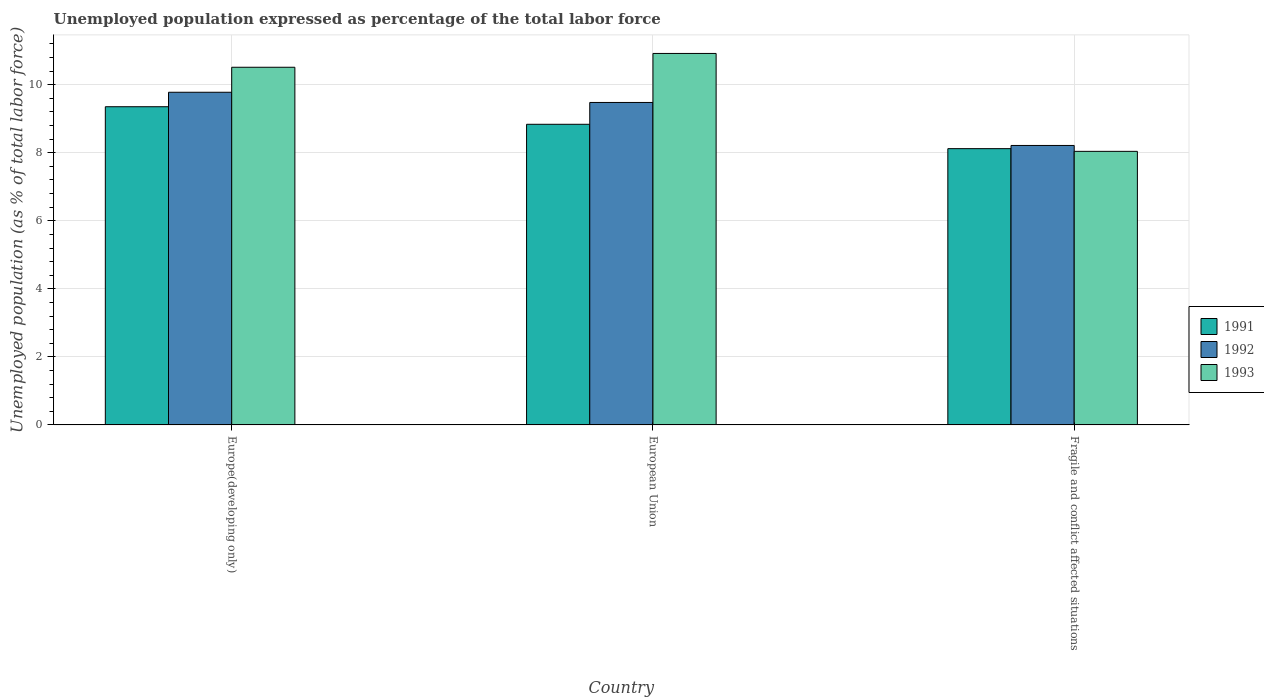How many groups of bars are there?
Give a very brief answer. 3. How many bars are there on the 3rd tick from the left?
Your answer should be very brief. 3. What is the label of the 1st group of bars from the left?
Make the answer very short. Europe(developing only). What is the unemployment in in 1992 in Europe(developing only)?
Provide a short and direct response. 9.78. Across all countries, what is the maximum unemployment in in 1993?
Your answer should be compact. 10.92. Across all countries, what is the minimum unemployment in in 1992?
Provide a short and direct response. 8.22. In which country was the unemployment in in 1992 minimum?
Your answer should be compact. Fragile and conflict affected situations. What is the total unemployment in in 1992 in the graph?
Your answer should be compact. 27.47. What is the difference between the unemployment in in 1992 in Europe(developing only) and that in European Union?
Ensure brevity in your answer.  0.3. What is the difference between the unemployment in in 1991 in Fragile and conflict affected situations and the unemployment in in 1992 in European Union?
Provide a short and direct response. -1.36. What is the average unemployment in in 1991 per country?
Your answer should be compact. 8.77. What is the difference between the unemployment in of/in 1991 and unemployment in of/in 1992 in Europe(developing only)?
Ensure brevity in your answer.  -0.43. What is the ratio of the unemployment in in 1991 in Europe(developing only) to that in European Union?
Offer a very short reply. 1.06. Is the unemployment in in 1993 in Europe(developing only) less than that in Fragile and conflict affected situations?
Your response must be concise. No. Is the difference between the unemployment in in 1991 in European Union and Fragile and conflict affected situations greater than the difference between the unemployment in in 1992 in European Union and Fragile and conflict affected situations?
Ensure brevity in your answer.  No. What is the difference between the highest and the second highest unemployment in in 1991?
Make the answer very short. -0.52. What is the difference between the highest and the lowest unemployment in in 1993?
Give a very brief answer. 2.88. What does the 1st bar from the left in Europe(developing only) represents?
Your response must be concise. 1991. How many bars are there?
Keep it short and to the point. 9. Are all the bars in the graph horizontal?
Your answer should be very brief. No. How many countries are there in the graph?
Keep it short and to the point. 3. Are the values on the major ticks of Y-axis written in scientific E-notation?
Keep it short and to the point. No. Does the graph contain any zero values?
Offer a very short reply. No. How many legend labels are there?
Your answer should be very brief. 3. How are the legend labels stacked?
Provide a succinct answer. Vertical. What is the title of the graph?
Offer a terse response. Unemployed population expressed as percentage of the total labor force. What is the label or title of the Y-axis?
Keep it short and to the point. Unemployed population (as % of total labor force). What is the Unemployed population (as % of total labor force) of 1991 in Europe(developing only)?
Provide a short and direct response. 9.35. What is the Unemployed population (as % of total labor force) in 1992 in Europe(developing only)?
Provide a short and direct response. 9.78. What is the Unemployed population (as % of total labor force) in 1993 in Europe(developing only)?
Offer a very short reply. 10.51. What is the Unemployed population (as % of total labor force) in 1991 in European Union?
Offer a very short reply. 8.84. What is the Unemployed population (as % of total labor force) in 1992 in European Union?
Offer a very short reply. 9.48. What is the Unemployed population (as % of total labor force) of 1993 in European Union?
Your response must be concise. 10.92. What is the Unemployed population (as % of total labor force) of 1991 in Fragile and conflict affected situations?
Ensure brevity in your answer.  8.12. What is the Unemployed population (as % of total labor force) of 1992 in Fragile and conflict affected situations?
Provide a succinct answer. 8.22. What is the Unemployed population (as % of total labor force) in 1993 in Fragile and conflict affected situations?
Ensure brevity in your answer.  8.04. Across all countries, what is the maximum Unemployed population (as % of total labor force) of 1991?
Give a very brief answer. 9.35. Across all countries, what is the maximum Unemployed population (as % of total labor force) in 1992?
Offer a very short reply. 9.78. Across all countries, what is the maximum Unemployed population (as % of total labor force) of 1993?
Provide a short and direct response. 10.92. Across all countries, what is the minimum Unemployed population (as % of total labor force) of 1991?
Keep it short and to the point. 8.12. Across all countries, what is the minimum Unemployed population (as % of total labor force) in 1992?
Your answer should be very brief. 8.22. Across all countries, what is the minimum Unemployed population (as % of total labor force) of 1993?
Your answer should be compact. 8.04. What is the total Unemployed population (as % of total labor force) of 1991 in the graph?
Give a very brief answer. 26.31. What is the total Unemployed population (as % of total labor force) of 1992 in the graph?
Offer a terse response. 27.47. What is the total Unemployed population (as % of total labor force) in 1993 in the graph?
Your response must be concise. 29.48. What is the difference between the Unemployed population (as % of total labor force) in 1991 in Europe(developing only) and that in European Union?
Provide a short and direct response. 0.52. What is the difference between the Unemployed population (as % of total labor force) in 1992 in Europe(developing only) and that in European Union?
Your answer should be very brief. 0.3. What is the difference between the Unemployed population (as % of total labor force) of 1993 in Europe(developing only) and that in European Union?
Your answer should be compact. -0.41. What is the difference between the Unemployed population (as % of total labor force) of 1991 in Europe(developing only) and that in Fragile and conflict affected situations?
Offer a terse response. 1.23. What is the difference between the Unemployed population (as % of total labor force) in 1992 in Europe(developing only) and that in Fragile and conflict affected situations?
Offer a very short reply. 1.56. What is the difference between the Unemployed population (as % of total labor force) of 1993 in Europe(developing only) and that in Fragile and conflict affected situations?
Provide a short and direct response. 2.47. What is the difference between the Unemployed population (as % of total labor force) of 1991 in European Union and that in Fragile and conflict affected situations?
Your answer should be compact. 0.72. What is the difference between the Unemployed population (as % of total labor force) of 1992 in European Union and that in Fragile and conflict affected situations?
Keep it short and to the point. 1.26. What is the difference between the Unemployed population (as % of total labor force) in 1993 in European Union and that in Fragile and conflict affected situations?
Offer a terse response. 2.88. What is the difference between the Unemployed population (as % of total labor force) in 1991 in Europe(developing only) and the Unemployed population (as % of total labor force) in 1992 in European Union?
Provide a succinct answer. -0.13. What is the difference between the Unemployed population (as % of total labor force) in 1991 in Europe(developing only) and the Unemployed population (as % of total labor force) in 1993 in European Union?
Provide a short and direct response. -1.57. What is the difference between the Unemployed population (as % of total labor force) of 1992 in Europe(developing only) and the Unemployed population (as % of total labor force) of 1993 in European Union?
Give a very brief answer. -1.14. What is the difference between the Unemployed population (as % of total labor force) in 1991 in Europe(developing only) and the Unemployed population (as % of total labor force) in 1992 in Fragile and conflict affected situations?
Make the answer very short. 1.14. What is the difference between the Unemployed population (as % of total labor force) in 1991 in Europe(developing only) and the Unemployed population (as % of total labor force) in 1993 in Fragile and conflict affected situations?
Your response must be concise. 1.31. What is the difference between the Unemployed population (as % of total labor force) of 1992 in Europe(developing only) and the Unemployed population (as % of total labor force) of 1993 in Fragile and conflict affected situations?
Ensure brevity in your answer.  1.74. What is the difference between the Unemployed population (as % of total labor force) in 1991 in European Union and the Unemployed population (as % of total labor force) in 1992 in Fragile and conflict affected situations?
Provide a succinct answer. 0.62. What is the difference between the Unemployed population (as % of total labor force) in 1991 in European Union and the Unemployed population (as % of total labor force) in 1993 in Fragile and conflict affected situations?
Your response must be concise. 0.8. What is the difference between the Unemployed population (as % of total labor force) of 1992 in European Union and the Unemployed population (as % of total labor force) of 1993 in Fragile and conflict affected situations?
Give a very brief answer. 1.44. What is the average Unemployed population (as % of total labor force) of 1991 per country?
Offer a very short reply. 8.77. What is the average Unemployed population (as % of total labor force) in 1992 per country?
Provide a succinct answer. 9.16. What is the average Unemployed population (as % of total labor force) of 1993 per country?
Your response must be concise. 9.83. What is the difference between the Unemployed population (as % of total labor force) of 1991 and Unemployed population (as % of total labor force) of 1992 in Europe(developing only)?
Provide a short and direct response. -0.43. What is the difference between the Unemployed population (as % of total labor force) of 1991 and Unemployed population (as % of total labor force) of 1993 in Europe(developing only)?
Your answer should be compact. -1.16. What is the difference between the Unemployed population (as % of total labor force) in 1992 and Unemployed population (as % of total labor force) in 1993 in Europe(developing only)?
Provide a short and direct response. -0.73. What is the difference between the Unemployed population (as % of total labor force) of 1991 and Unemployed population (as % of total labor force) of 1992 in European Union?
Your response must be concise. -0.64. What is the difference between the Unemployed population (as % of total labor force) in 1991 and Unemployed population (as % of total labor force) in 1993 in European Union?
Ensure brevity in your answer.  -2.08. What is the difference between the Unemployed population (as % of total labor force) in 1992 and Unemployed population (as % of total labor force) in 1993 in European Union?
Your answer should be very brief. -1.44. What is the difference between the Unemployed population (as % of total labor force) of 1991 and Unemployed population (as % of total labor force) of 1992 in Fragile and conflict affected situations?
Provide a succinct answer. -0.09. What is the difference between the Unemployed population (as % of total labor force) in 1991 and Unemployed population (as % of total labor force) in 1993 in Fragile and conflict affected situations?
Make the answer very short. 0.08. What is the difference between the Unemployed population (as % of total labor force) in 1992 and Unemployed population (as % of total labor force) in 1993 in Fragile and conflict affected situations?
Your answer should be very brief. 0.17. What is the ratio of the Unemployed population (as % of total labor force) in 1991 in Europe(developing only) to that in European Union?
Offer a terse response. 1.06. What is the ratio of the Unemployed population (as % of total labor force) of 1992 in Europe(developing only) to that in European Union?
Make the answer very short. 1.03. What is the ratio of the Unemployed population (as % of total labor force) of 1993 in Europe(developing only) to that in European Union?
Keep it short and to the point. 0.96. What is the ratio of the Unemployed population (as % of total labor force) of 1991 in Europe(developing only) to that in Fragile and conflict affected situations?
Your answer should be compact. 1.15. What is the ratio of the Unemployed population (as % of total labor force) in 1992 in Europe(developing only) to that in Fragile and conflict affected situations?
Provide a short and direct response. 1.19. What is the ratio of the Unemployed population (as % of total labor force) in 1993 in Europe(developing only) to that in Fragile and conflict affected situations?
Ensure brevity in your answer.  1.31. What is the ratio of the Unemployed population (as % of total labor force) of 1991 in European Union to that in Fragile and conflict affected situations?
Give a very brief answer. 1.09. What is the ratio of the Unemployed population (as % of total labor force) of 1992 in European Union to that in Fragile and conflict affected situations?
Provide a short and direct response. 1.15. What is the ratio of the Unemployed population (as % of total labor force) in 1993 in European Union to that in Fragile and conflict affected situations?
Provide a succinct answer. 1.36. What is the difference between the highest and the second highest Unemployed population (as % of total labor force) of 1991?
Your answer should be compact. 0.52. What is the difference between the highest and the second highest Unemployed population (as % of total labor force) of 1992?
Your answer should be very brief. 0.3. What is the difference between the highest and the second highest Unemployed population (as % of total labor force) in 1993?
Provide a succinct answer. 0.41. What is the difference between the highest and the lowest Unemployed population (as % of total labor force) of 1991?
Offer a terse response. 1.23. What is the difference between the highest and the lowest Unemployed population (as % of total labor force) in 1992?
Keep it short and to the point. 1.56. What is the difference between the highest and the lowest Unemployed population (as % of total labor force) of 1993?
Make the answer very short. 2.88. 